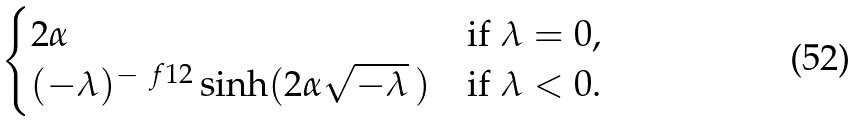<formula> <loc_0><loc_0><loc_500><loc_500>\begin{cases} 2 \alpha & \text {if } \lambda = 0 , \\ ( - \lambda ) ^ { - \ f 1 2 } \sinh ( 2 \alpha \sqrt { - \lambda } \, ) & \text {if } \lambda < 0 . \end{cases}</formula> 